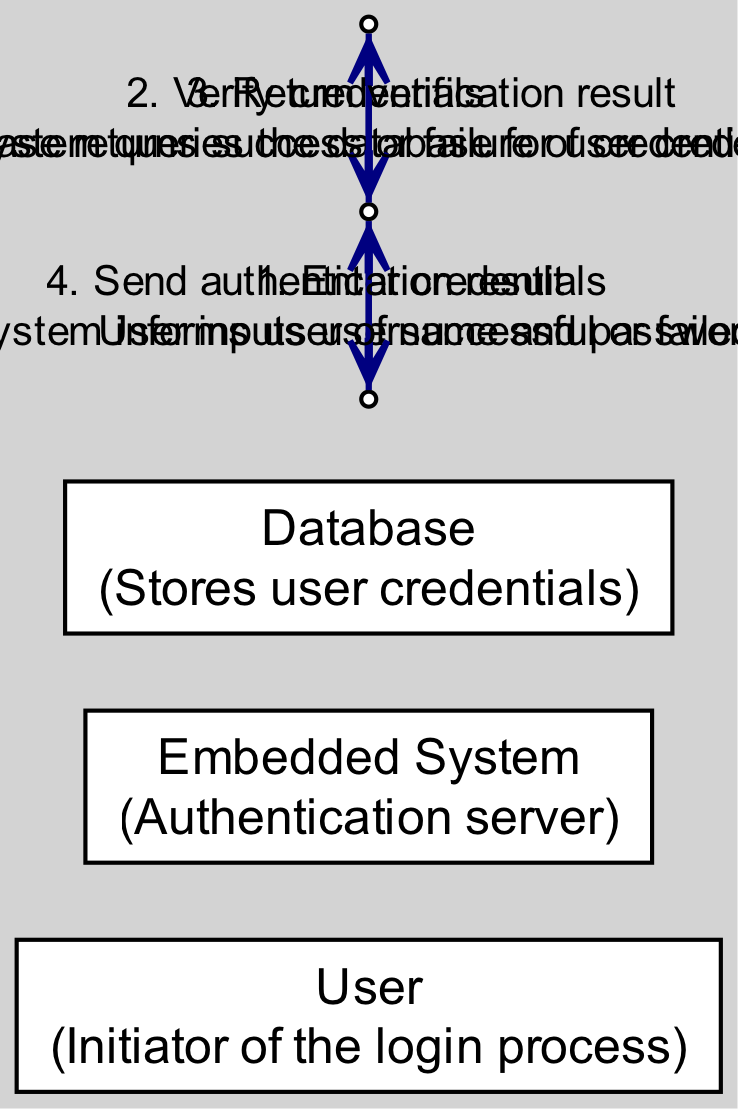What is the first action performed in the sequence? The first action performed in the sequence is the user entering their credentials. This is indicated as the first message from the User to the Embedded System in the diagram.
Answer: Enter credentials How many actors are involved in the diagram? There are three actors involved in the diagram: the User, the Embedded System, and the Database. This can be counted from the list of actors presented in the diagram.
Answer: Three What does the Embedded System do after verifying the credentials? After verifying the credentials, the Embedded System sends the authentication result back to the User, as noted in the message flow.
Answer: Send authentication result Which actor receives the verification result? The Embedded System receives the verification result from the Database. This is visible in the message flow where the Database communicates back to the Embedded System.
Answer: Embedded System What message is sent from the Database to the Embedded System? The message sent from the Database to the Embedded System is the return of the verification result. This is specified in the diagram's message flow.
Answer: Return verification result What action follows the user's input of credentials? The action that follows the user's input of credentials is the verification of those credentials by the Embedded System. This can be deduced from the sequence of messages in the diagram.
Answer: Verify credentials Which actor initiates the login process? The User is the actor that initiates the login process, as seen in the first message sent to the Embedded System.
Answer: User How many messages are exchanged between the actors? There are four messages exchanged between the actors. This includes the actions taken by each actor and can be counted directly from the message list in the diagram.
Answer: Four What is the last action described in the diagram? The last action described in the diagram is the Embedded System sending the authentication result to the User, which wraps up the sequence of interactions.
Answer: Send authentication result 